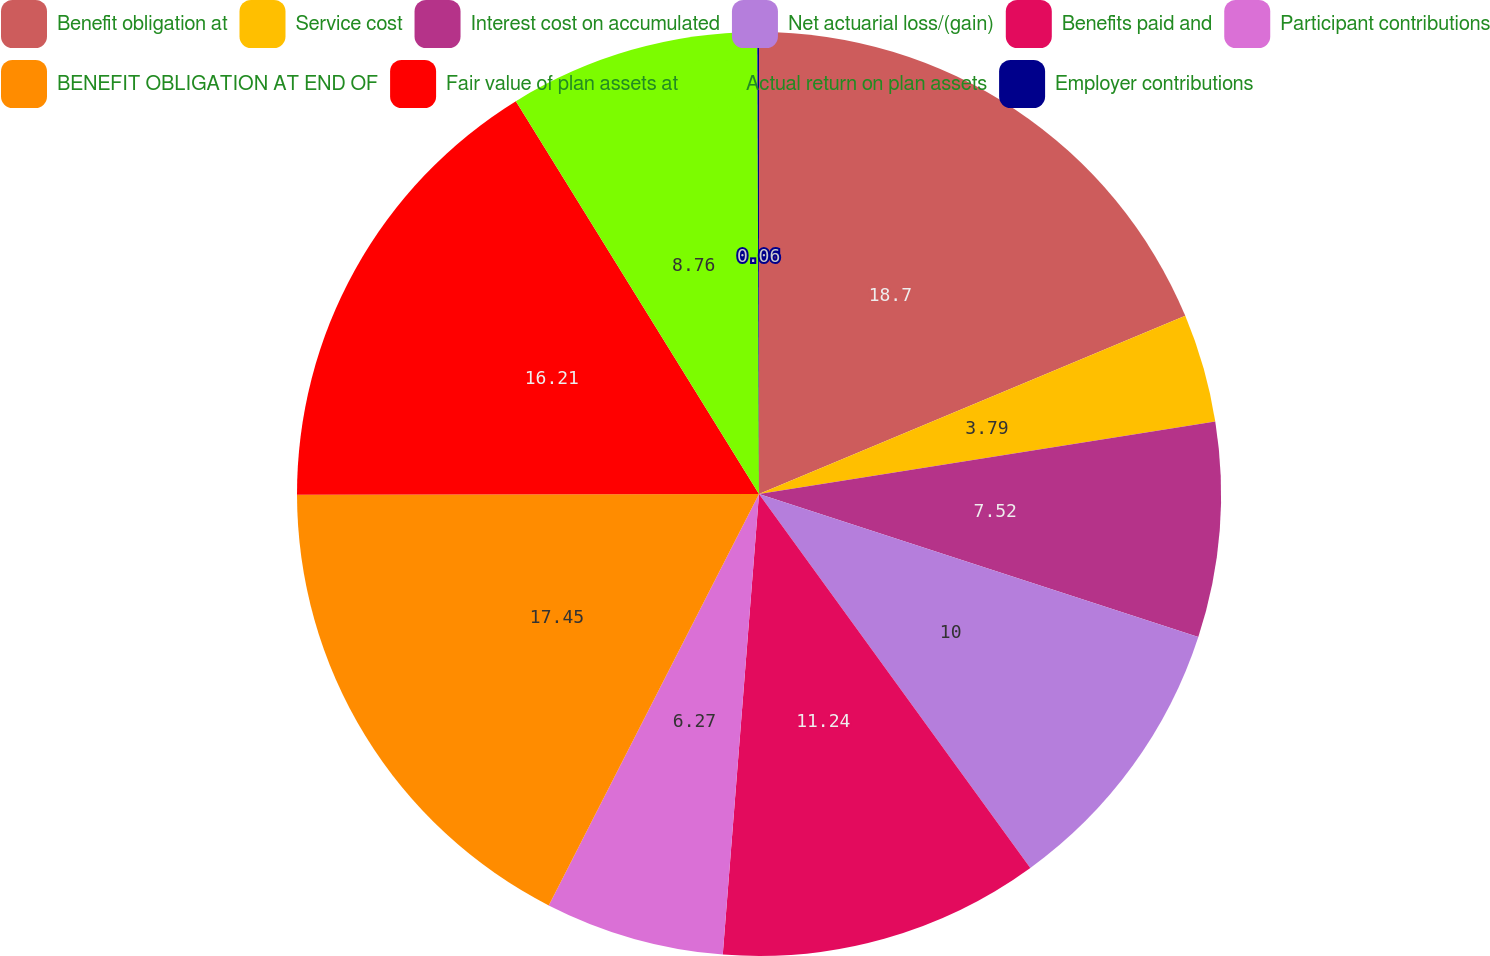Convert chart to OTSL. <chart><loc_0><loc_0><loc_500><loc_500><pie_chart><fcel>Benefit obligation at<fcel>Service cost<fcel>Interest cost on accumulated<fcel>Net actuarial loss/(gain)<fcel>Benefits paid and<fcel>Participant contributions<fcel>BENEFIT OBLIGATION AT END OF<fcel>Fair value of plan assets at<fcel>Actual return on plan assets<fcel>Employer contributions<nl><fcel>18.7%<fcel>3.79%<fcel>7.52%<fcel>10.0%<fcel>11.24%<fcel>6.27%<fcel>17.45%<fcel>16.21%<fcel>8.76%<fcel>0.06%<nl></chart> 